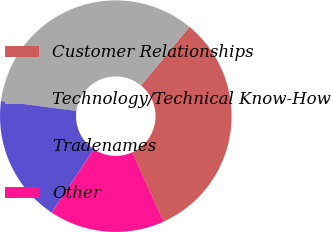Convert chart to OTSL. <chart><loc_0><loc_0><loc_500><loc_500><pie_chart><fcel>Customer Relationships<fcel>Technology/Technical Know-How<fcel>Tradenames<fcel>Other<nl><fcel>32.26%<fcel>33.88%<fcel>17.74%<fcel>16.12%<nl></chart> 